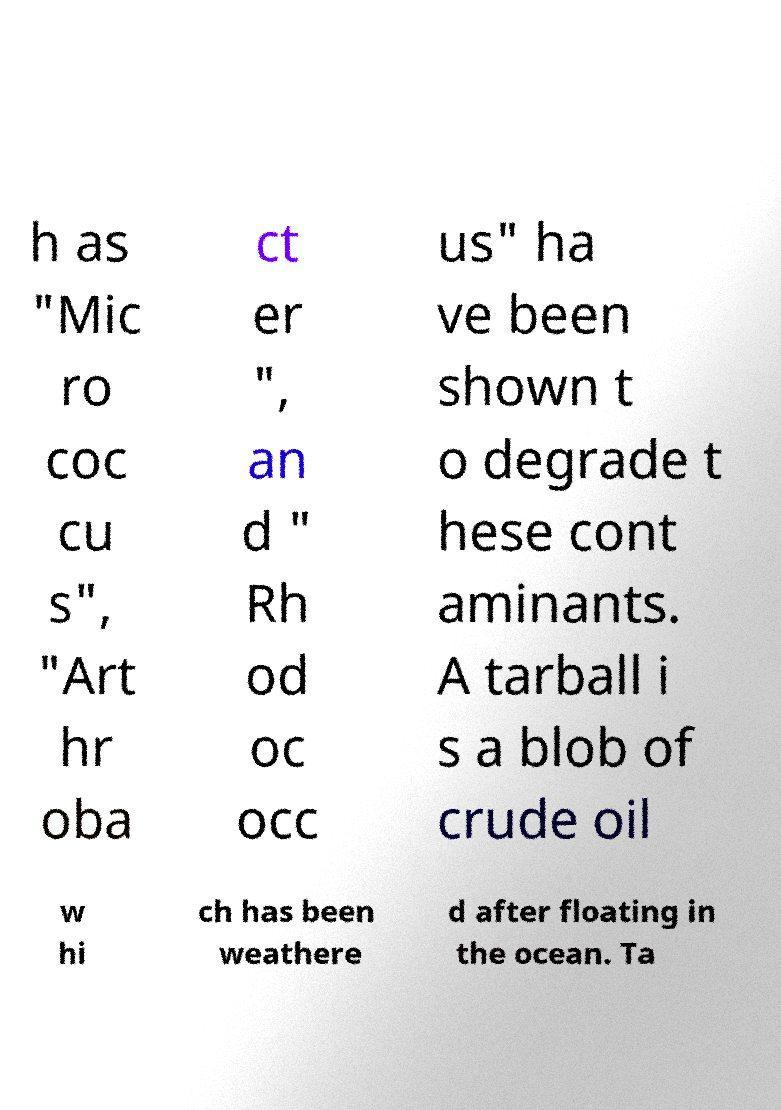Could you assist in decoding the text presented in this image and type it out clearly? h as "Mic ro coc cu s", "Art hr oba ct er ", an d " Rh od oc occ us" ha ve been shown t o degrade t hese cont aminants. A tarball i s a blob of crude oil w hi ch has been weathere d after floating in the ocean. Ta 